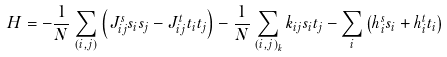Convert formula to latex. <formula><loc_0><loc_0><loc_500><loc_500>H = - \frac { 1 } { N } \sum _ { ( i , j ) } \left ( J ^ { s } _ { i j } s _ { i } s _ { j } - J ^ { t } _ { i j } t _ { i } t _ { j } \right ) - \frac { 1 } { N } \sum _ { ( i , j ) _ { k } } k _ { i j } s _ { i } t _ { j } - \sum _ { i } \left ( h ^ { s } _ { i } s _ { i } + h ^ { t } _ { i } t _ { i } \right )</formula> 